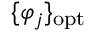Convert formula to latex. <formula><loc_0><loc_0><loc_500><loc_500>\{ \varphi _ { j } \} _ { o p t }</formula> 